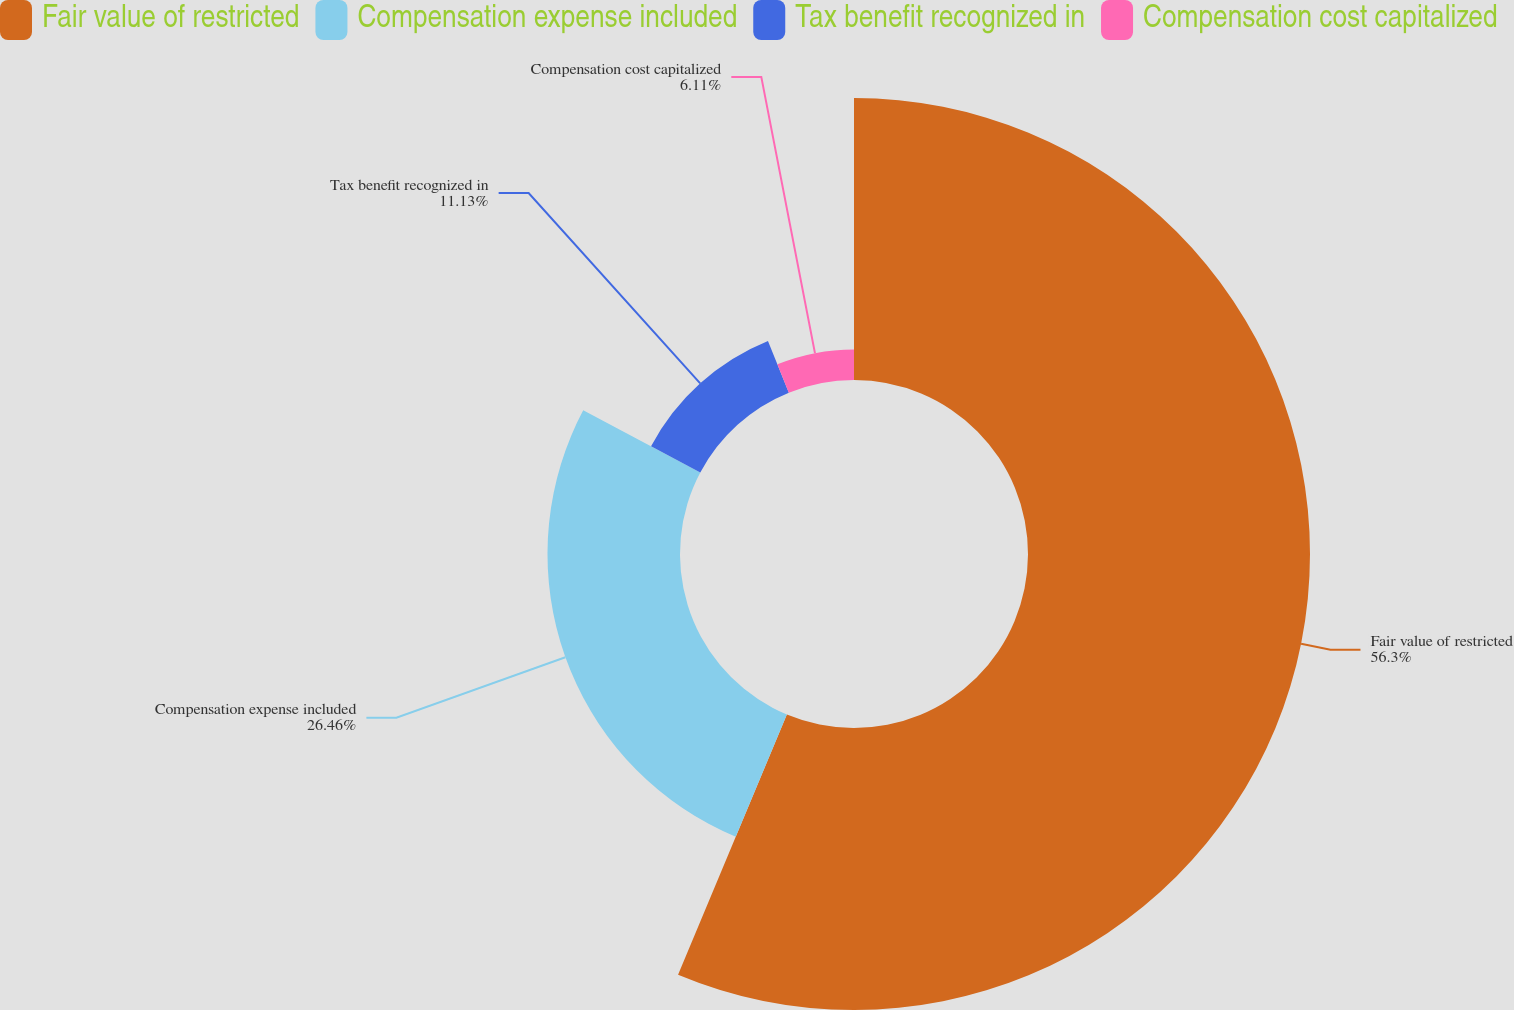<chart> <loc_0><loc_0><loc_500><loc_500><pie_chart><fcel>Fair value of restricted<fcel>Compensation expense included<fcel>Tax benefit recognized in<fcel>Compensation cost capitalized<nl><fcel>56.31%<fcel>26.46%<fcel>11.13%<fcel>6.11%<nl></chart> 